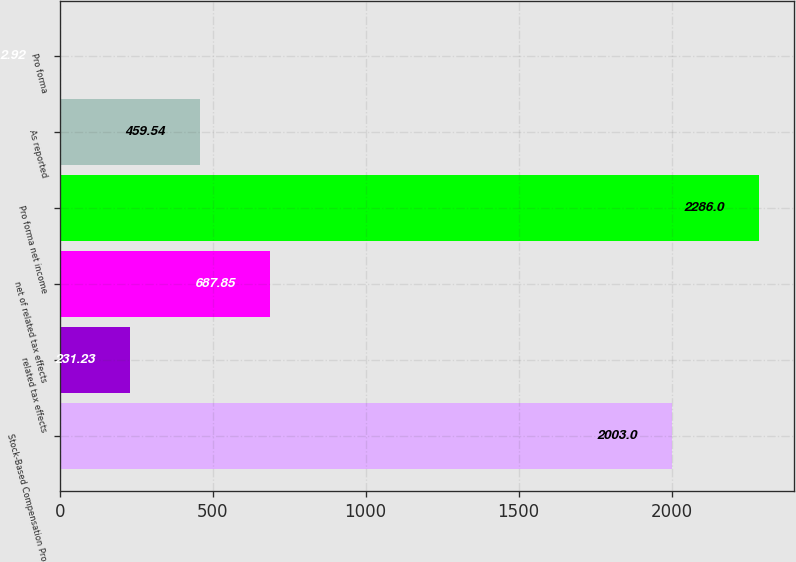Convert chart to OTSL. <chart><loc_0><loc_0><loc_500><loc_500><bar_chart><fcel>Stock-Based Compensation Pro<fcel>related tax effects<fcel>net of related tax effects<fcel>Pro forma net income<fcel>As reported<fcel>Pro forma<nl><fcel>2003<fcel>231.23<fcel>687.85<fcel>2286<fcel>459.54<fcel>2.92<nl></chart> 